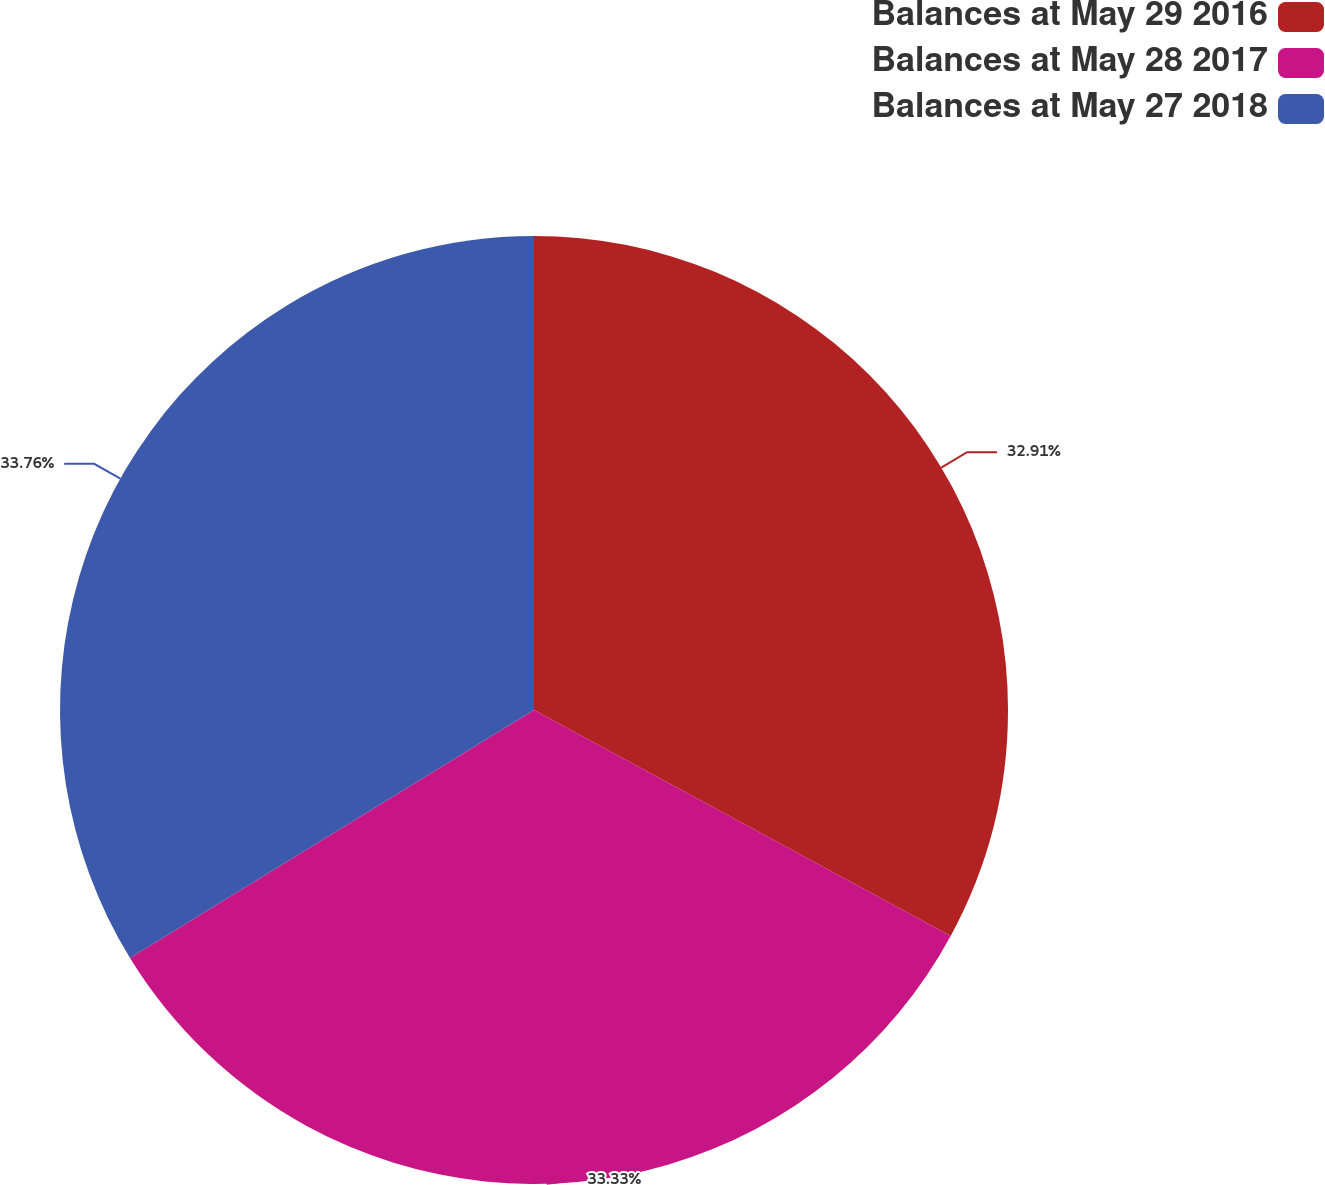Convert chart. <chart><loc_0><loc_0><loc_500><loc_500><pie_chart><fcel>Balances at May 29 2016<fcel>Balances at May 28 2017<fcel>Balances at May 27 2018<nl><fcel>32.91%<fcel>33.33%<fcel>33.76%<nl></chart> 